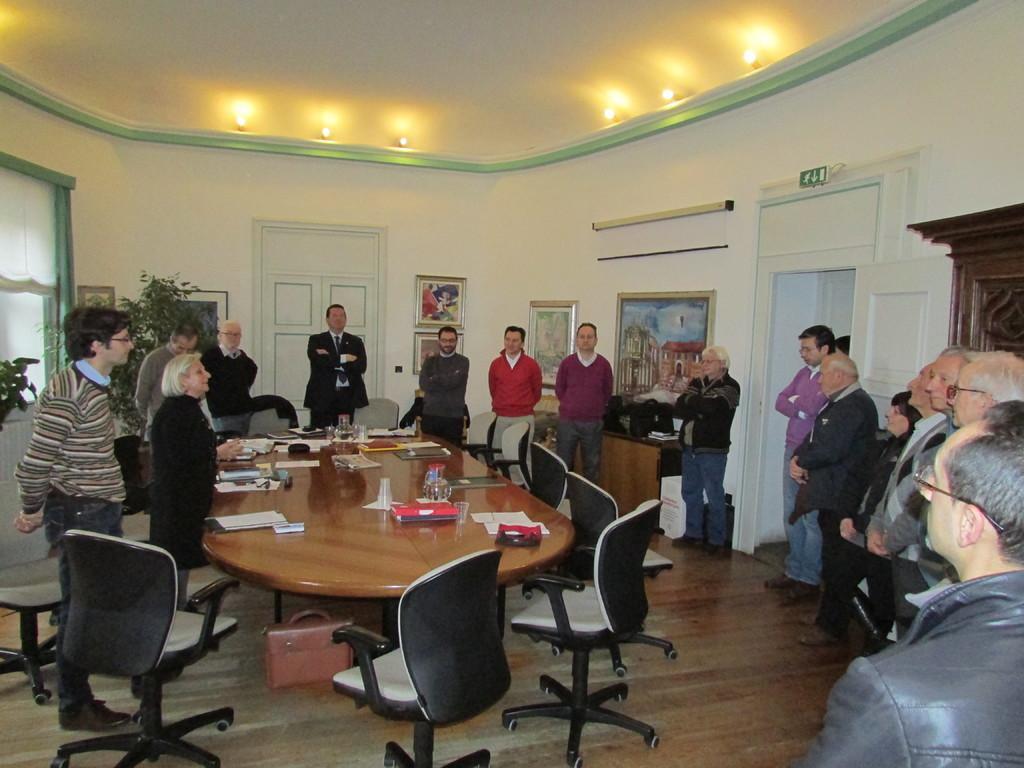Describe this image in one or two sentences. The image is inside the room. In the image there are group of people standing in front of a table. On table we can see a paper,glass,book and we can also see some chairs. On right side there are group of people standing and a door which is in white color,frames. on left side there is a wall which is in white color,window,curtains,photo frames,plants with green leaves. In background there is a wall on top there is a roof with few lights and at bottom we can see a light. 